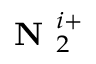<formula> <loc_0><loc_0><loc_500><loc_500>N _ { 2 } ^ { i + }</formula> 